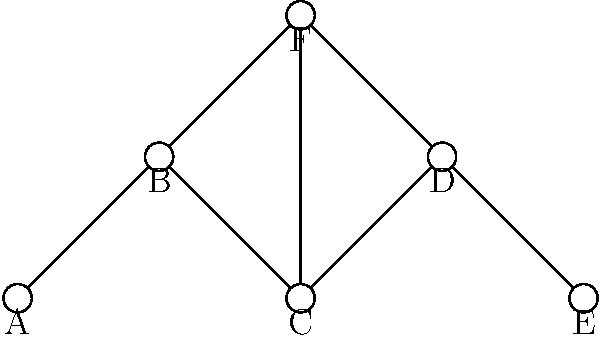In the network topology shown above, which node(s) would be most critical to protect in a DDoS attack scenario to maintain the network's overall connectivity? Assume all connections have equal bandwidth. To identify the most critical node(s) in this DDoS attack scenario, we need to analyze the network topology and determine which node(s), if compromised, would cause the most significant disruption to the network's connectivity. Here's a step-by-step approach:

1. Evaluate node connectivity:
   Node A: 1 connection
   Node B: 2 connections
   Node C: 3 connections
   Node D: 2 connections
   Node E: 1 connection
   Node F: 3 connections

2. Identify potential bottlenecks:
   Nodes C and F have the highest number of connections (3 each).

3. Analyze the impact of removing each node:
   - Removing A or E would only isolate that node.
   - Removing B or D would create two separate components.
   - Removing C would disconnect A and B from the rest of the network.
   - Removing F would disconnect B, C, and D from each other.

4. Consider centrality:
   Node C is more central to the network's overall structure compared to F.

5. Evaluate the network's resilience:
   If C is compromised, the network becomes much more vulnerable to further attacks.

Based on this analysis, node C is the most critical to protect. It has the highest number of connections, is central to the network's structure, and its compromise would significantly impact the network's overall connectivity.
Answer: Node C 